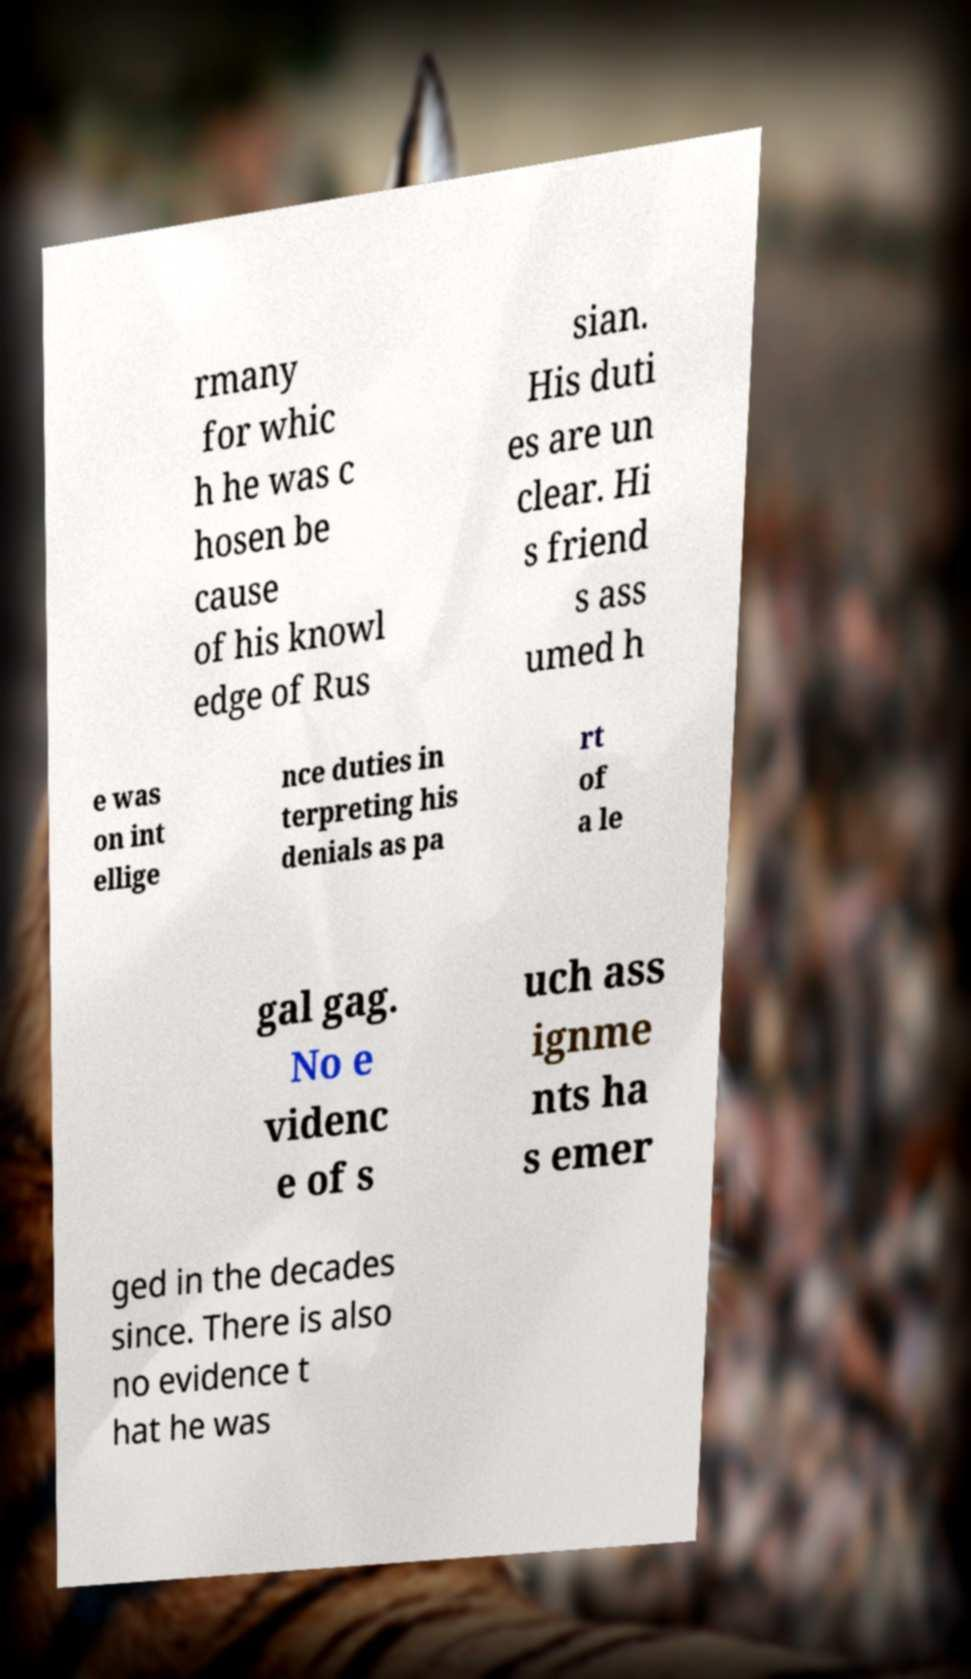What messages or text are displayed in this image? I need them in a readable, typed format. rmany for whic h he was c hosen be cause of his knowl edge of Rus sian. His duti es are un clear. Hi s friend s ass umed h e was on int ellige nce duties in terpreting his denials as pa rt of a le gal gag. No e videnc e of s uch ass ignme nts ha s emer ged in the decades since. There is also no evidence t hat he was 